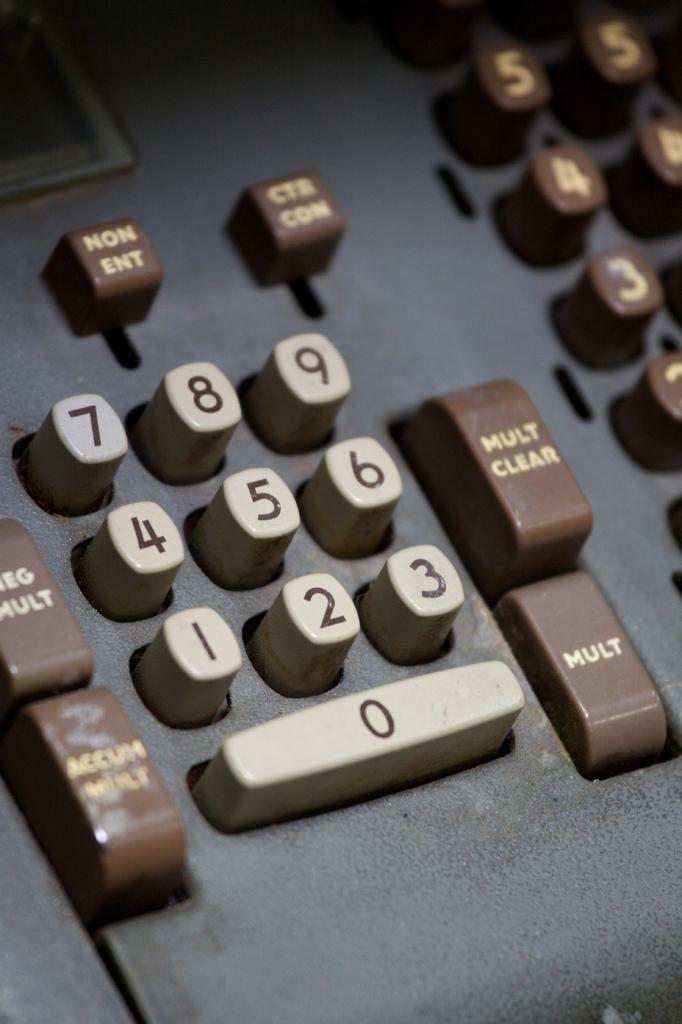<image>
Render a clear and concise summary of the photo. An old adding machine with special buttons for Mult Clear, Mult and others. 